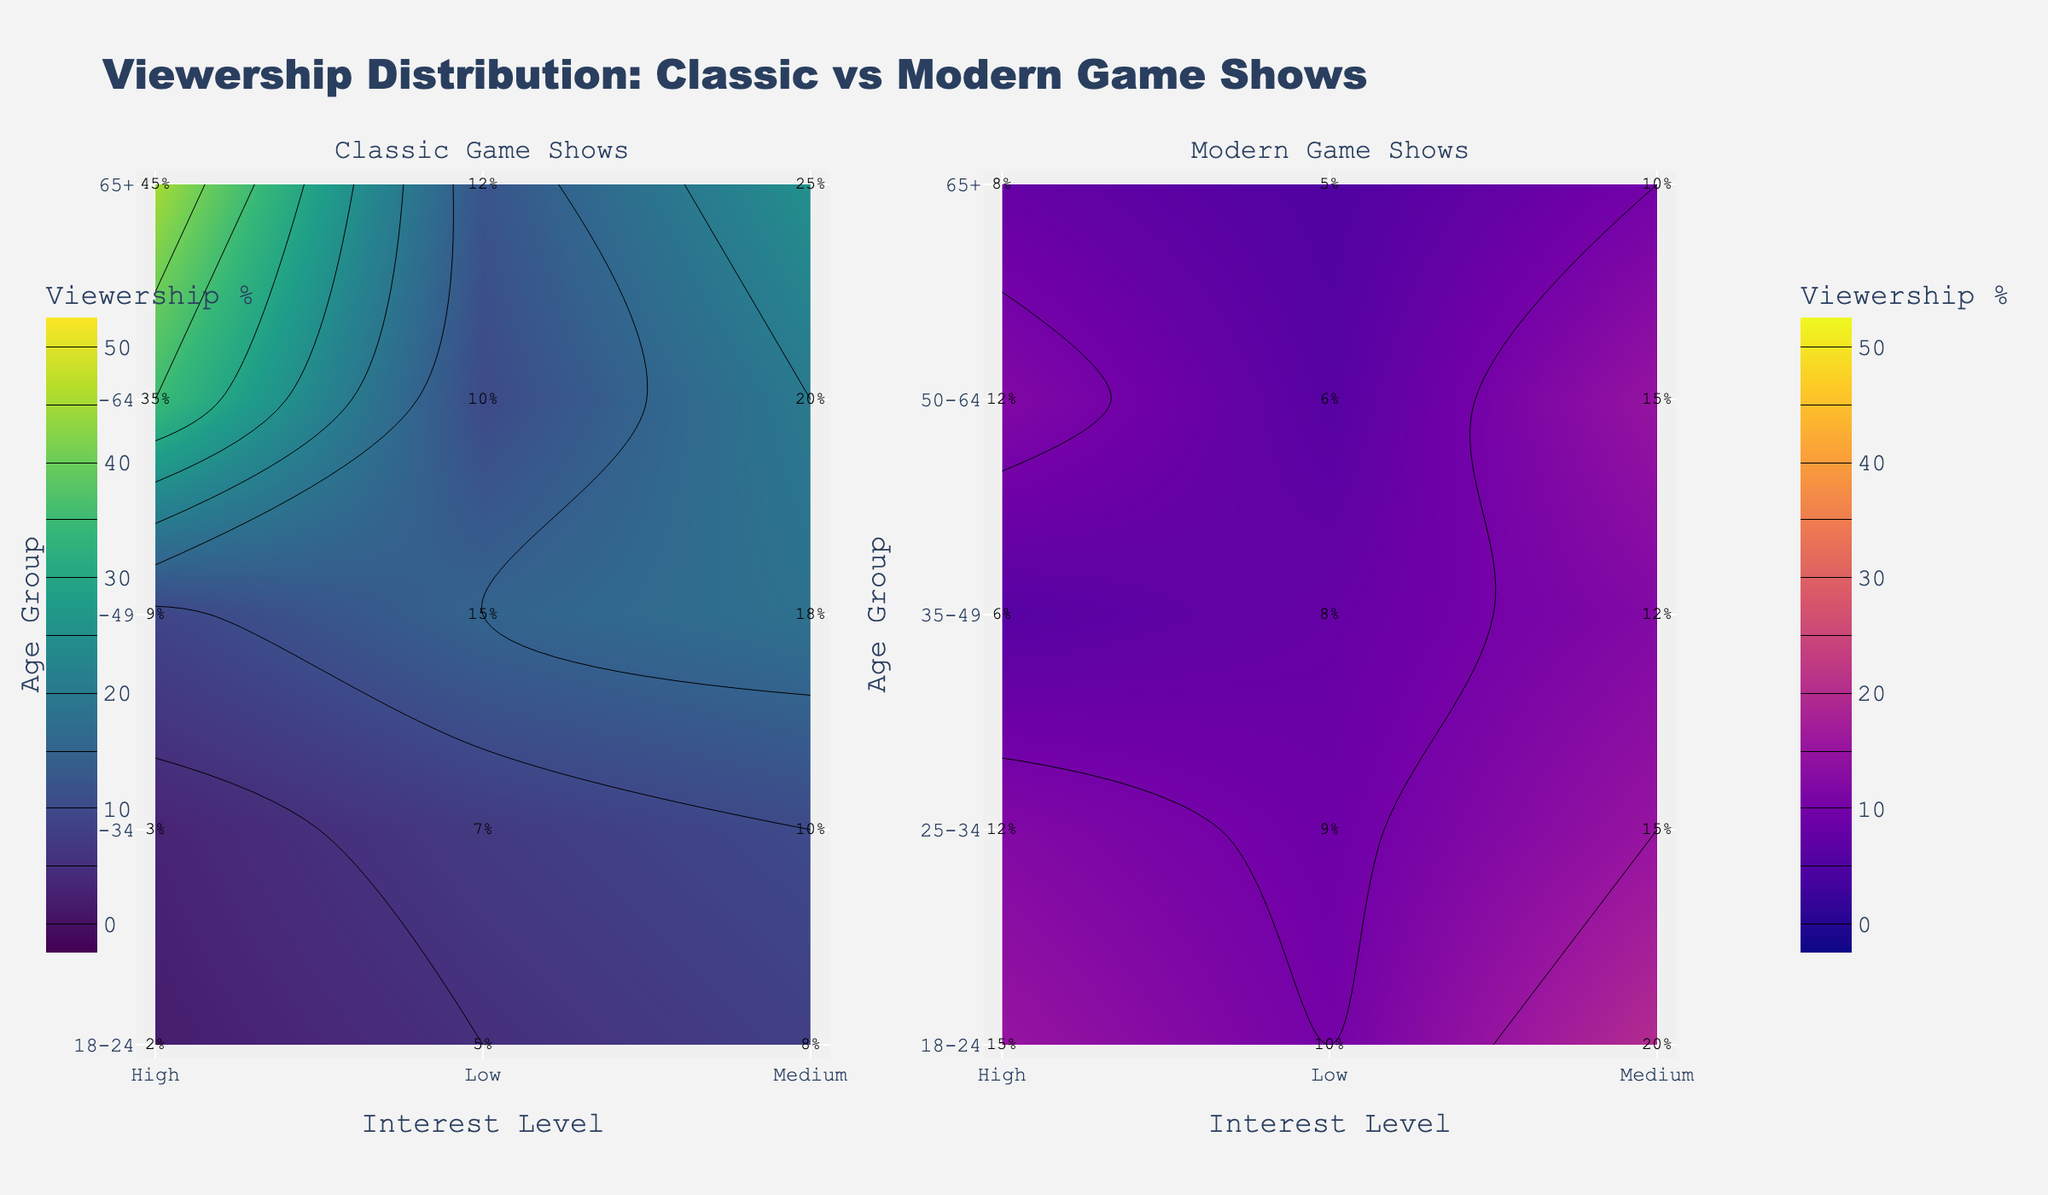What's the title of the figure? The title is prominently placed at the top of the figure. It reads: "Viewership Distribution: Classic vs Modern Game Shows"
Answer: Viewership Distribution: Classic vs Modern Game Shows What color schemes are used for the classic and modern game show plots? The classic game show plot uses the 'Viridis' colorscale, and the modern game show plot uses the 'Plasma' colorscale. These can be identified by the distinct color patterns in each subplot.
Answer: Viridis and Plasma Which age group shows the highest viewership percentage for high-interest classic game shows? The annotations on the classic game show subplot show that the age group 65+ has the highest viewership percentage for high-interest classic game shows, marked as 45%.
Answer: 65+ How does the viewership percentage for medium interest change from 18-24 to 65+ for classic game shows? To answer this, look at the annotations in the classic game show subplot for "Medium" interest. The values are: 18-24 (8%), 25-34 (10%), 35-49 (18%), 50-64 (20%), and 65+ (25%). The percentage gradually increases with each ascending age group.
Answer: Increases What is the viewership percentage for low and high-interest modern game shows in the 35-49 age group? Find the 35-49 age group in the modern game show subplot. The annotations indicate the viewership percentages are 8% (Low) and 6% (High).
Answer: 8% (Low), 6% (High) Which age groups show a higher preference for classic game shows than modern ones? Compare the viewership percentages in each age group for both classic and modern games. The age groups 35-49, 50-64, and 65+ have higher overall viewership percentages for classic game shows compared to modern ones.
Answer: 35-49, 50-64, 65+ What's the difference in viewership percentage between medium-interest modern game shows and medium-interest classic game shows in the 18-24 age group? Check the annotations in the 18-24 age group for both subplots: Modern (20%) and Classic (8%). The difference is calculated as 20% - 8% = 12%.
Answer: 12% Which interest level shows the most significant variation in viewership percentages across different age groups for classic game shows? Examine the contour lines and annotations for classic game shows. The 'High' interest level shows a significant variation, especially increasing drastically in older age groups ranging from 2% (18-24) to 45% (65+).
Answer: High Is the viewership for high-interest game shows generally higher in classic or modern game shows for all age groups? By comparing the annotations for 'High' interest levels across all age groups, we can see that classic game shows generally have higher percentages: 2%(18-24), 3%(25-34), 9%(35-49), 35%(50-64), and 45%(65+), versus modern: 15%(18-24), 12%(25-34), 6%(35-49), 12%(50-64), 8%(65+).
Answer: Classic Looking at both subplots, are modern game shows more favored by younger or older age groups compared to classic game shows? Younger age groups prefer modern shows as indicated by higher percentages in 18-24 (45%) and 25-34 (36%) compared to classic shows (15% and 20%). Classic shows are more favored by older groups (50-64 and 65+).
Answer: Younger 